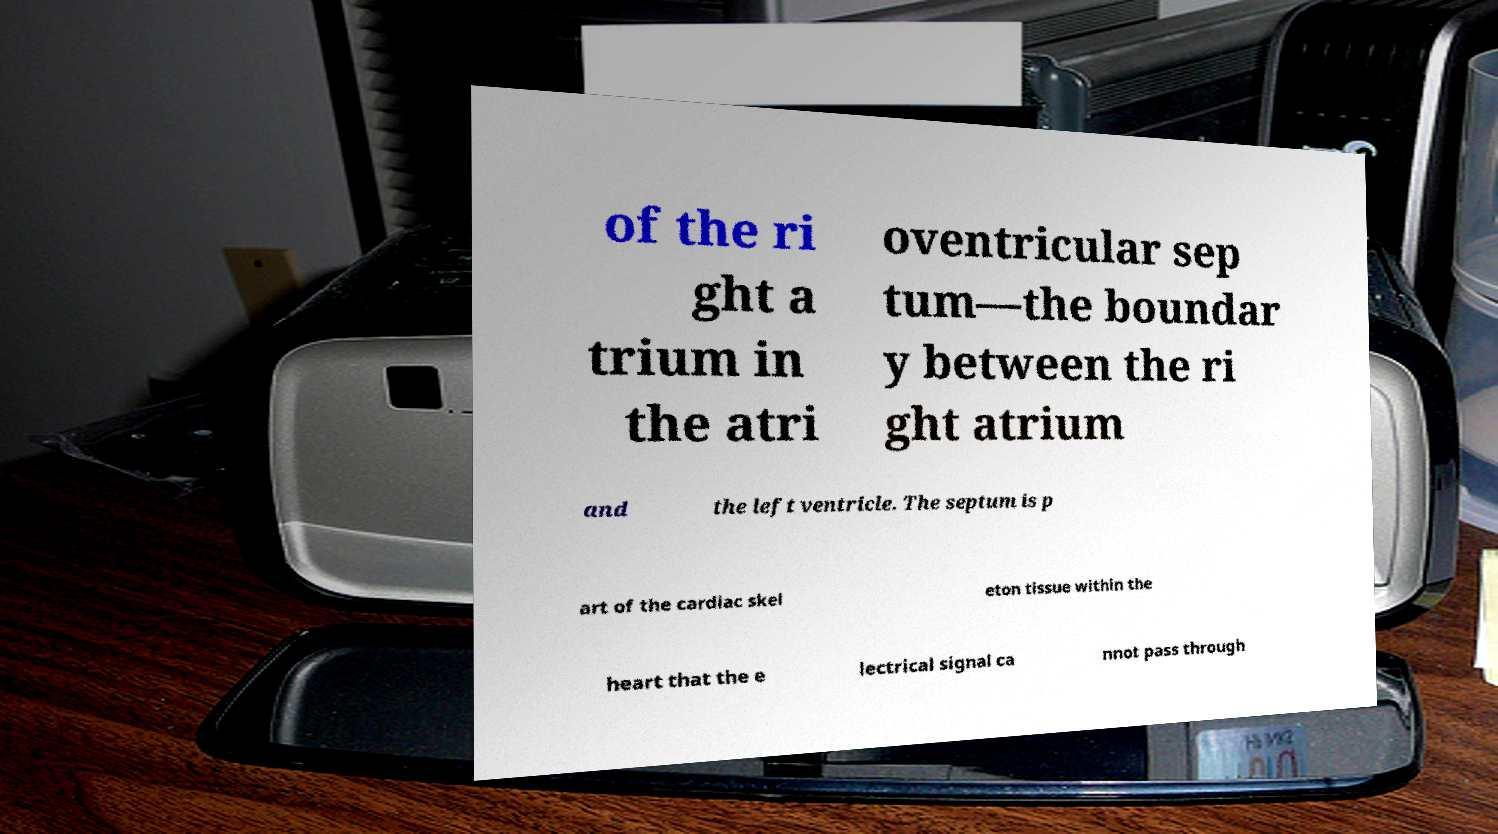For documentation purposes, I need the text within this image transcribed. Could you provide that? of the ri ght a trium in the atri oventricular sep tum—the boundar y between the ri ght atrium and the left ventricle. The septum is p art of the cardiac skel eton tissue within the heart that the e lectrical signal ca nnot pass through 